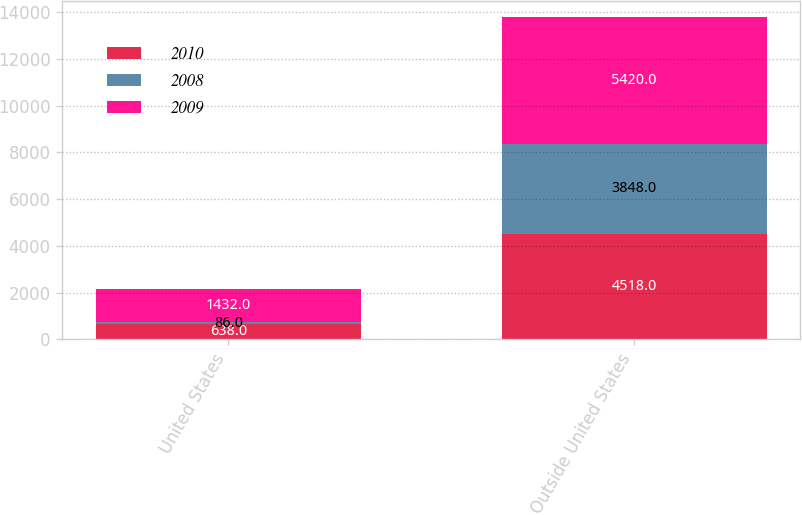Convert chart. <chart><loc_0><loc_0><loc_500><loc_500><stacked_bar_chart><ecel><fcel>United States<fcel>Outside United States<nl><fcel>2010<fcel>638<fcel>4518<nl><fcel>2008<fcel>86<fcel>3848<nl><fcel>2009<fcel>1432<fcel>5420<nl></chart> 